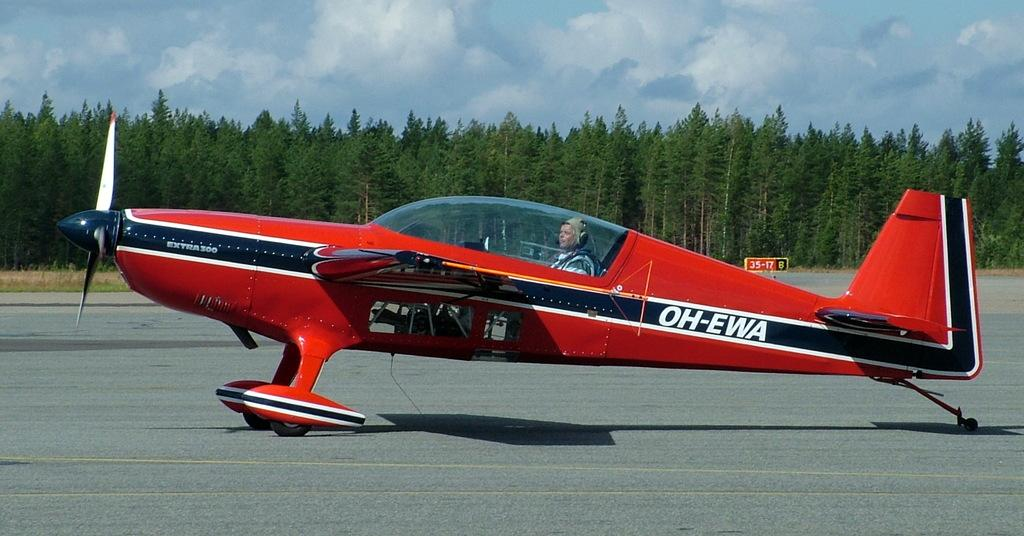<image>
Give a short and clear explanation of the subsequent image. A red airplane with the letters OH-EWA on the side 